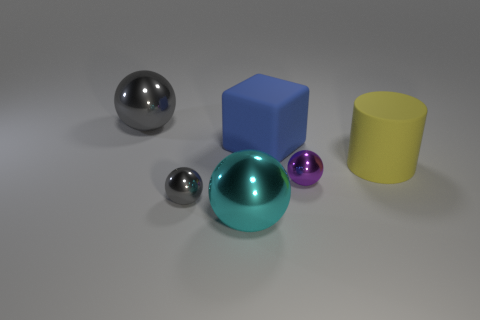Add 1 yellow cylinders. How many objects exist? 7 Subtract all blocks. How many objects are left? 5 Add 2 tiny things. How many tiny things exist? 4 Subtract 0 purple cubes. How many objects are left? 6 Subtract all green rubber cubes. Subtract all yellow matte cylinders. How many objects are left? 5 Add 4 large gray metal things. How many large gray metal things are left? 5 